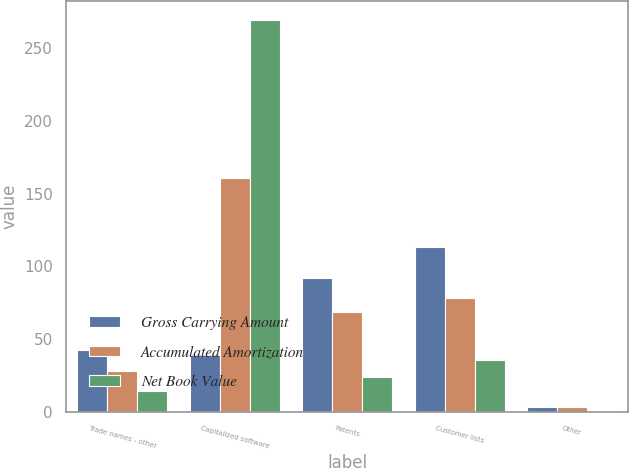Convert chart. <chart><loc_0><loc_0><loc_500><loc_500><stacked_bar_chart><ecel><fcel>Trade names - other<fcel>Capitalized software<fcel>Patents<fcel>Customer lists<fcel>Other<nl><fcel>Gross Carrying Amount<fcel>42.1<fcel>38.85<fcel>92.2<fcel>113.5<fcel>3.1<nl><fcel>Accumulated Amortization<fcel>28<fcel>160.7<fcel>68.2<fcel>77.9<fcel>3<nl><fcel>Net Book Value<fcel>14.1<fcel>269.2<fcel>24<fcel>35.6<fcel>0.1<nl></chart> 